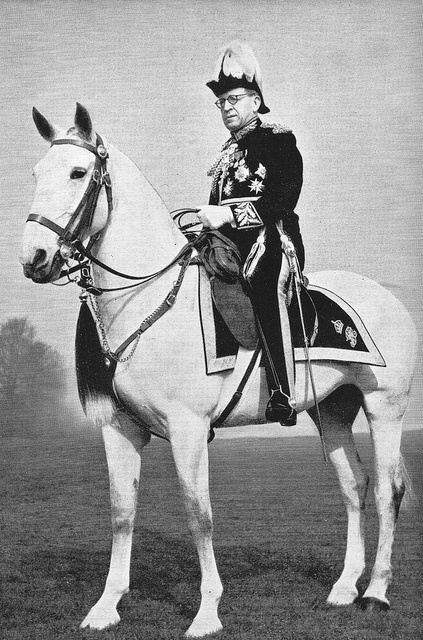Describe the objects in this image and their specific colors. I can see horse in darkgray, lightgray, gray, and black tones, people in darkgray, black, lightgray, and gray tones, and handbag in darkgray, black, gray, and lightgray tones in this image. 